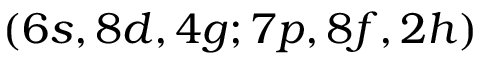<formula> <loc_0><loc_0><loc_500><loc_500>( 6 s , 8 d , 4 g ; 7 p , 8 f , 2 h )</formula> 